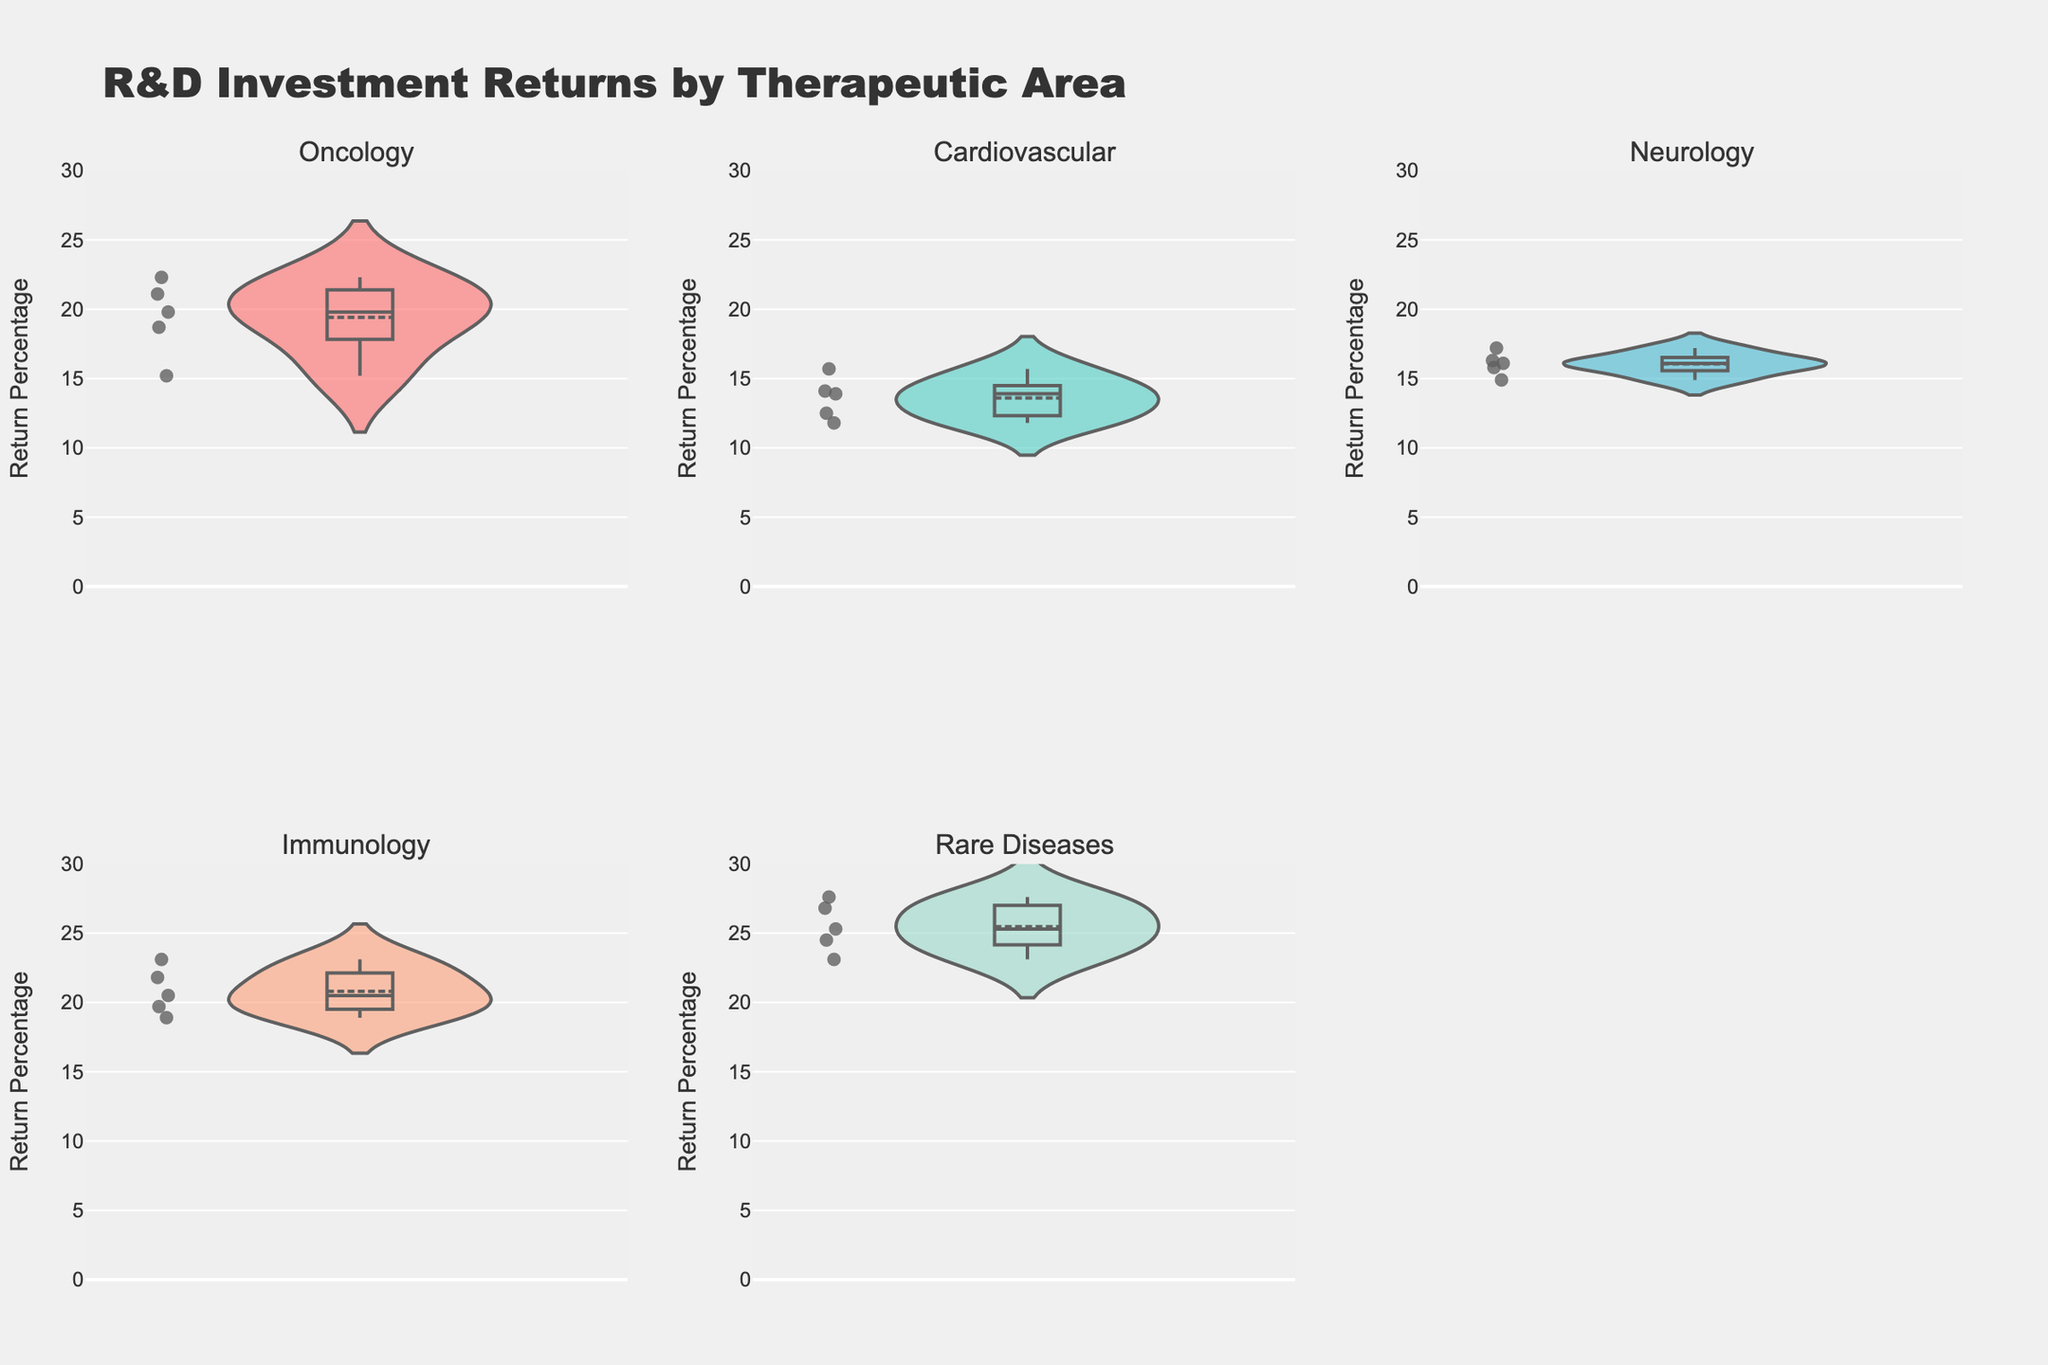What's the title of the figure? The title can be found at the top of the figure. This is typically a descriptive phrase summarizing the content of the plot.
Answer: R&D Investment Returns by Therapeutic Area How many therapeutic areas are presented in the figure? You can identify the therapeutic areas by looking at the subplot titles or the x-axis labels within each subplot.
Answer: Five Which therapeutic area shows the highest median return percentage? By looking at the meanline within each violin plot in the subplots, you can identify which area has the highest median value.
Answer: Rare Diseases What color represents the Neurology therapeutic area? Each therapeutic area is represented by a different color in the violin plots, noted in the figure legend or by matching colors directly.
Answer: Blue (approx. #45B7D1) What is the average return percentage for the Immunology therapeutic area? Calculate the average by summing all return percentages for Immunology and dividing by the number of data points (5). (20.5 + 18.9 + 23.1 + 19.7 + 21.8) / 5 = 20.8
Answer: 20.8 Which therapeutic area has the widest range of return percentages? The range can be determined by finding the difference between the highest and lowest points visible in each violin plot. Rare Diseases show the widest spread from low 20s to high 20s.
Answer: Rare Diseases Is the median return percentage higher in Oncology or Cardiovascular therapeutic areas? By comparing the meanline in the Oncology and Cardiovascular subplots, you can see which one is higher.
Answer: Oncology How does the return percentage distribution for Immunology compare to that for Neurology? Immunology shows a slightly higher return percentage range and median compared to Neurology. Immunology has returns mostly between ~18.9% and ~23.1%, while Neurology ranges from ~14.9% to ~17.2%.
Answer: Immunology has higher median and range Are there any outliers in the Oncology therapeutic area return percentages? Since points are displayed as jittered dots on the violin plots, you can visually inspect for any points that are significantly away from the majority.
Answer: No noticeable outliers Which therapeutic area has the lowest variability in return percentages? Variability can be estimated by the spread of the return percentages in the violin plot. Cardiovascular shows the narrowest distribution.
Answer: Cardiovascular 